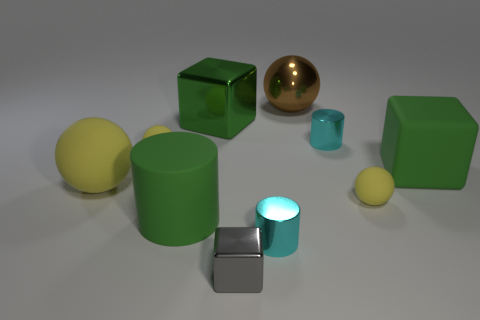Subtract all purple cylinders. How many yellow spheres are left? 3 Subtract 1 cylinders. How many cylinders are left? 2 Subtract all brown spheres. How many spheres are left? 3 Subtract all large brown spheres. How many spheres are left? 3 Subtract all green spheres. Subtract all gray cylinders. How many spheres are left? 4 Subtract all cylinders. How many objects are left? 7 Subtract all small purple shiny cylinders. Subtract all big brown objects. How many objects are left? 9 Add 3 tiny gray objects. How many tiny gray objects are left? 4 Add 4 large brown shiny things. How many large brown shiny things exist? 5 Subtract 0 yellow cylinders. How many objects are left? 10 